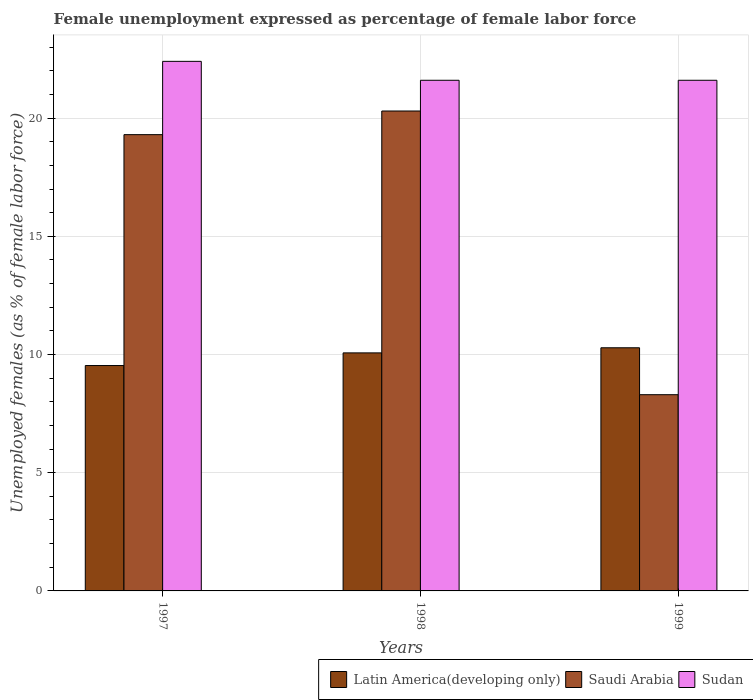How many different coloured bars are there?
Offer a terse response. 3. Are the number of bars per tick equal to the number of legend labels?
Your response must be concise. Yes. How many bars are there on the 2nd tick from the left?
Keep it short and to the point. 3. How many bars are there on the 1st tick from the right?
Keep it short and to the point. 3. What is the label of the 1st group of bars from the left?
Your answer should be very brief. 1997. In how many cases, is the number of bars for a given year not equal to the number of legend labels?
Provide a short and direct response. 0. What is the unemployment in females in in Sudan in 1997?
Your answer should be compact. 22.4. Across all years, what is the maximum unemployment in females in in Saudi Arabia?
Provide a succinct answer. 20.3. Across all years, what is the minimum unemployment in females in in Saudi Arabia?
Your response must be concise. 8.3. In which year was the unemployment in females in in Latin America(developing only) minimum?
Make the answer very short. 1997. What is the total unemployment in females in in Saudi Arabia in the graph?
Keep it short and to the point. 47.9. What is the difference between the unemployment in females in in Latin America(developing only) in 1997 and that in 1998?
Your answer should be compact. -0.53. What is the difference between the unemployment in females in in Sudan in 1997 and the unemployment in females in in Latin America(developing only) in 1999?
Your response must be concise. 12.12. What is the average unemployment in females in in Saudi Arabia per year?
Keep it short and to the point. 15.97. In the year 1997, what is the difference between the unemployment in females in in Saudi Arabia and unemployment in females in in Latin America(developing only)?
Keep it short and to the point. 9.77. In how many years, is the unemployment in females in in Saudi Arabia greater than 21 %?
Make the answer very short. 0. What is the ratio of the unemployment in females in in Sudan in 1997 to that in 1999?
Ensure brevity in your answer.  1.04. Is the unemployment in females in in Sudan in 1998 less than that in 1999?
Provide a short and direct response. No. What is the difference between the highest and the second highest unemployment in females in in Sudan?
Keep it short and to the point. 0.8. What is the difference between the highest and the lowest unemployment in females in in Saudi Arabia?
Offer a very short reply. 12. In how many years, is the unemployment in females in in Latin America(developing only) greater than the average unemployment in females in in Latin America(developing only) taken over all years?
Your response must be concise. 2. Is the sum of the unemployment in females in in Saudi Arabia in 1997 and 1999 greater than the maximum unemployment in females in in Sudan across all years?
Keep it short and to the point. Yes. What does the 3rd bar from the left in 1999 represents?
Your response must be concise. Sudan. What does the 3rd bar from the right in 1997 represents?
Give a very brief answer. Latin America(developing only). Is it the case that in every year, the sum of the unemployment in females in in Latin America(developing only) and unemployment in females in in Saudi Arabia is greater than the unemployment in females in in Sudan?
Provide a short and direct response. No. How many bars are there?
Give a very brief answer. 9. Are all the bars in the graph horizontal?
Offer a very short reply. No. How many years are there in the graph?
Keep it short and to the point. 3. What is the difference between two consecutive major ticks on the Y-axis?
Your answer should be very brief. 5. Where does the legend appear in the graph?
Provide a short and direct response. Bottom right. How are the legend labels stacked?
Ensure brevity in your answer.  Horizontal. What is the title of the graph?
Give a very brief answer. Female unemployment expressed as percentage of female labor force. Does "Cuba" appear as one of the legend labels in the graph?
Make the answer very short. No. What is the label or title of the X-axis?
Keep it short and to the point. Years. What is the label or title of the Y-axis?
Ensure brevity in your answer.  Unemployed females (as % of female labor force). What is the Unemployed females (as % of female labor force) of Latin America(developing only) in 1997?
Give a very brief answer. 9.53. What is the Unemployed females (as % of female labor force) of Saudi Arabia in 1997?
Offer a terse response. 19.3. What is the Unemployed females (as % of female labor force) in Sudan in 1997?
Provide a short and direct response. 22.4. What is the Unemployed females (as % of female labor force) of Latin America(developing only) in 1998?
Provide a succinct answer. 10.07. What is the Unemployed females (as % of female labor force) of Saudi Arabia in 1998?
Your answer should be very brief. 20.3. What is the Unemployed females (as % of female labor force) in Sudan in 1998?
Your answer should be very brief. 21.6. What is the Unemployed females (as % of female labor force) of Latin America(developing only) in 1999?
Keep it short and to the point. 10.28. What is the Unemployed females (as % of female labor force) of Saudi Arabia in 1999?
Ensure brevity in your answer.  8.3. What is the Unemployed females (as % of female labor force) in Sudan in 1999?
Your response must be concise. 21.6. Across all years, what is the maximum Unemployed females (as % of female labor force) in Latin America(developing only)?
Your answer should be compact. 10.28. Across all years, what is the maximum Unemployed females (as % of female labor force) in Saudi Arabia?
Keep it short and to the point. 20.3. Across all years, what is the maximum Unemployed females (as % of female labor force) in Sudan?
Your answer should be very brief. 22.4. Across all years, what is the minimum Unemployed females (as % of female labor force) of Latin America(developing only)?
Your response must be concise. 9.53. Across all years, what is the minimum Unemployed females (as % of female labor force) of Saudi Arabia?
Your answer should be compact. 8.3. Across all years, what is the minimum Unemployed females (as % of female labor force) in Sudan?
Provide a short and direct response. 21.6. What is the total Unemployed females (as % of female labor force) of Latin America(developing only) in the graph?
Make the answer very short. 29.89. What is the total Unemployed females (as % of female labor force) of Saudi Arabia in the graph?
Your response must be concise. 47.9. What is the total Unemployed females (as % of female labor force) in Sudan in the graph?
Make the answer very short. 65.6. What is the difference between the Unemployed females (as % of female labor force) in Latin America(developing only) in 1997 and that in 1998?
Offer a terse response. -0.54. What is the difference between the Unemployed females (as % of female labor force) in Saudi Arabia in 1997 and that in 1998?
Your answer should be compact. -1. What is the difference between the Unemployed females (as % of female labor force) in Latin America(developing only) in 1997 and that in 1999?
Ensure brevity in your answer.  -0.75. What is the difference between the Unemployed females (as % of female labor force) of Saudi Arabia in 1997 and that in 1999?
Give a very brief answer. 11. What is the difference between the Unemployed females (as % of female labor force) of Latin America(developing only) in 1998 and that in 1999?
Keep it short and to the point. -0.22. What is the difference between the Unemployed females (as % of female labor force) in Sudan in 1998 and that in 1999?
Provide a short and direct response. 0. What is the difference between the Unemployed females (as % of female labor force) in Latin America(developing only) in 1997 and the Unemployed females (as % of female labor force) in Saudi Arabia in 1998?
Your response must be concise. -10.77. What is the difference between the Unemployed females (as % of female labor force) in Latin America(developing only) in 1997 and the Unemployed females (as % of female labor force) in Sudan in 1998?
Your answer should be very brief. -12.07. What is the difference between the Unemployed females (as % of female labor force) in Saudi Arabia in 1997 and the Unemployed females (as % of female labor force) in Sudan in 1998?
Ensure brevity in your answer.  -2.3. What is the difference between the Unemployed females (as % of female labor force) of Latin America(developing only) in 1997 and the Unemployed females (as % of female labor force) of Saudi Arabia in 1999?
Your answer should be compact. 1.23. What is the difference between the Unemployed females (as % of female labor force) in Latin America(developing only) in 1997 and the Unemployed females (as % of female labor force) in Sudan in 1999?
Your response must be concise. -12.07. What is the difference between the Unemployed females (as % of female labor force) in Saudi Arabia in 1997 and the Unemployed females (as % of female labor force) in Sudan in 1999?
Ensure brevity in your answer.  -2.3. What is the difference between the Unemployed females (as % of female labor force) of Latin America(developing only) in 1998 and the Unemployed females (as % of female labor force) of Saudi Arabia in 1999?
Offer a terse response. 1.77. What is the difference between the Unemployed females (as % of female labor force) in Latin America(developing only) in 1998 and the Unemployed females (as % of female labor force) in Sudan in 1999?
Your response must be concise. -11.53. What is the average Unemployed females (as % of female labor force) in Latin America(developing only) per year?
Your answer should be compact. 9.96. What is the average Unemployed females (as % of female labor force) in Saudi Arabia per year?
Your response must be concise. 15.97. What is the average Unemployed females (as % of female labor force) of Sudan per year?
Your response must be concise. 21.87. In the year 1997, what is the difference between the Unemployed females (as % of female labor force) in Latin America(developing only) and Unemployed females (as % of female labor force) in Saudi Arabia?
Your response must be concise. -9.77. In the year 1997, what is the difference between the Unemployed females (as % of female labor force) in Latin America(developing only) and Unemployed females (as % of female labor force) in Sudan?
Provide a succinct answer. -12.87. In the year 1998, what is the difference between the Unemployed females (as % of female labor force) of Latin America(developing only) and Unemployed females (as % of female labor force) of Saudi Arabia?
Give a very brief answer. -10.23. In the year 1998, what is the difference between the Unemployed females (as % of female labor force) of Latin America(developing only) and Unemployed females (as % of female labor force) of Sudan?
Your answer should be compact. -11.53. In the year 1998, what is the difference between the Unemployed females (as % of female labor force) in Saudi Arabia and Unemployed females (as % of female labor force) in Sudan?
Your response must be concise. -1.3. In the year 1999, what is the difference between the Unemployed females (as % of female labor force) of Latin America(developing only) and Unemployed females (as % of female labor force) of Saudi Arabia?
Offer a very short reply. 1.98. In the year 1999, what is the difference between the Unemployed females (as % of female labor force) of Latin America(developing only) and Unemployed females (as % of female labor force) of Sudan?
Your response must be concise. -11.32. What is the ratio of the Unemployed females (as % of female labor force) in Latin America(developing only) in 1997 to that in 1998?
Provide a short and direct response. 0.95. What is the ratio of the Unemployed females (as % of female labor force) of Saudi Arabia in 1997 to that in 1998?
Make the answer very short. 0.95. What is the ratio of the Unemployed females (as % of female labor force) of Sudan in 1997 to that in 1998?
Give a very brief answer. 1.04. What is the ratio of the Unemployed females (as % of female labor force) of Latin America(developing only) in 1997 to that in 1999?
Your response must be concise. 0.93. What is the ratio of the Unemployed females (as % of female labor force) in Saudi Arabia in 1997 to that in 1999?
Give a very brief answer. 2.33. What is the ratio of the Unemployed females (as % of female labor force) of Sudan in 1997 to that in 1999?
Give a very brief answer. 1.04. What is the ratio of the Unemployed females (as % of female labor force) of Saudi Arabia in 1998 to that in 1999?
Give a very brief answer. 2.45. What is the difference between the highest and the second highest Unemployed females (as % of female labor force) of Latin America(developing only)?
Give a very brief answer. 0.22. What is the difference between the highest and the second highest Unemployed females (as % of female labor force) in Sudan?
Your answer should be very brief. 0.8. What is the difference between the highest and the lowest Unemployed females (as % of female labor force) of Latin America(developing only)?
Your answer should be compact. 0.75. 